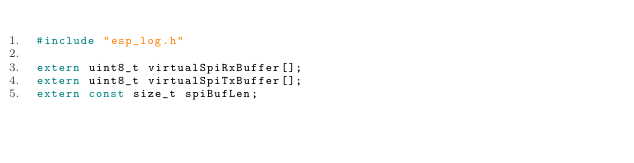Convert code to text. <code><loc_0><loc_0><loc_500><loc_500><_C_>#include "esp_log.h"

extern uint8_t virtualSpiRxBuffer[];
extern uint8_t virtualSpiTxBuffer[];
extern const size_t spiBufLen;
</code> 